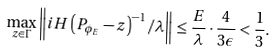Convert formula to latex. <formula><loc_0><loc_0><loc_500><loc_500>\max _ { z \in \Gamma } \left \| i H \left ( P _ { \phi _ { E } } - z \right ) ^ { - 1 } / \lambda \right \| \leq \frac { E } { \lambda } \cdot \frac { 4 } { 3 \epsilon } < \frac { 1 } { 3 } .</formula> 